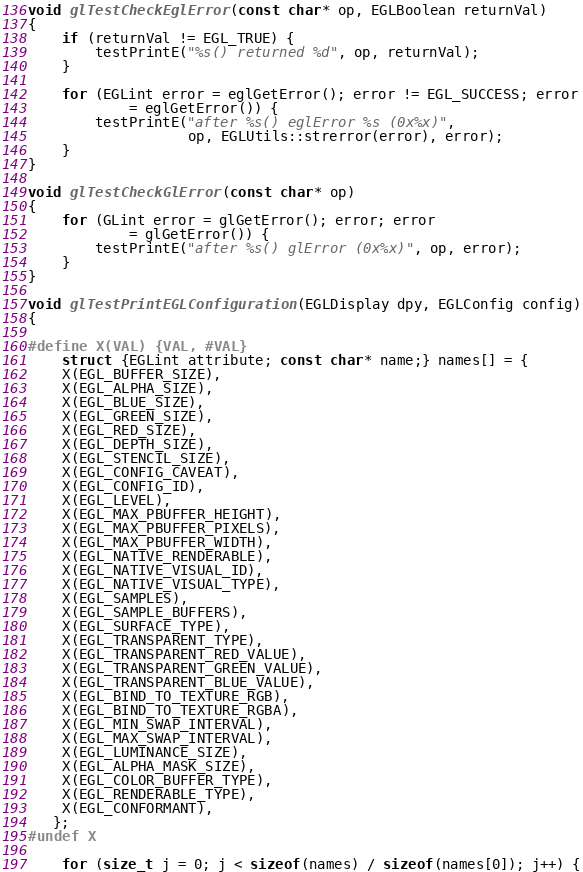<code> <loc_0><loc_0><loc_500><loc_500><_C++_>void glTestCheckEglError(const char* op, EGLBoolean returnVal)
{
    if (returnVal != EGL_TRUE) {
        testPrintE("%s() returned %d", op, returnVal);
    }

    for (EGLint error = eglGetError(); error != EGL_SUCCESS; error
            = eglGetError()) {
        testPrintE("after %s() eglError %s (0x%x)",
                   op, EGLUtils::strerror(error), error);
    }
}

void glTestCheckGlError(const char* op)
{
    for (GLint error = glGetError(); error; error
            = glGetError()) {
        testPrintE("after %s() glError (0x%x)", op, error);
    }
}

void glTestPrintEGLConfiguration(EGLDisplay dpy, EGLConfig config)
{

#define X(VAL) {VAL, #VAL}
    struct {EGLint attribute; const char* name;} names[] = {
    X(EGL_BUFFER_SIZE),
    X(EGL_ALPHA_SIZE),
    X(EGL_BLUE_SIZE),
    X(EGL_GREEN_SIZE),
    X(EGL_RED_SIZE),
    X(EGL_DEPTH_SIZE),
    X(EGL_STENCIL_SIZE),
    X(EGL_CONFIG_CAVEAT),
    X(EGL_CONFIG_ID),
    X(EGL_LEVEL),
    X(EGL_MAX_PBUFFER_HEIGHT),
    X(EGL_MAX_PBUFFER_PIXELS),
    X(EGL_MAX_PBUFFER_WIDTH),
    X(EGL_NATIVE_RENDERABLE),
    X(EGL_NATIVE_VISUAL_ID),
    X(EGL_NATIVE_VISUAL_TYPE),
    X(EGL_SAMPLES),
    X(EGL_SAMPLE_BUFFERS),
    X(EGL_SURFACE_TYPE),
    X(EGL_TRANSPARENT_TYPE),
    X(EGL_TRANSPARENT_RED_VALUE),
    X(EGL_TRANSPARENT_GREEN_VALUE),
    X(EGL_TRANSPARENT_BLUE_VALUE),
    X(EGL_BIND_TO_TEXTURE_RGB),
    X(EGL_BIND_TO_TEXTURE_RGBA),
    X(EGL_MIN_SWAP_INTERVAL),
    X(EGL_MAX_SWAP_INTERVAL),
    X(EGL_LUMINANCE_SIZE),
    X(EGL_ALPHA_MASK_SIZE),
    X(EGL_COLOR_BUFFER_TYPE),
    X(EGL_RENDERABLE_TYPE),
    X(EGL_CONFORMANT),
   };
#undef X

    for (size_t j = 0; j < sizeof(names) / sizeof(names[0]); j++) {</code> 